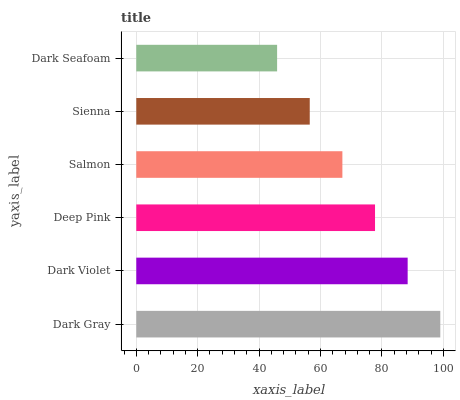Is Dark Seafoam the minimum?
Answer yes or no. Yes. Is Dark Gray the maximum?
Answer yes or no. Yes. Is Dark Violet the minimum?
Answer yes or no. No. Is Dark Violet the maximum?
Answer yes or no. No. Is Dark Gray greater than Dark Violet?
Answer yes or no. Yes. Is Dark Violet less than Dark Gray?
Answer yes or no. Yes. Is Dark Violet greater than Dark Gray?
Answer yes or no. No. Is Dark Gray less than Dark Violet?
Answer yes or no. No. Is Deep Pink the high median?
Answer yes or no. Yes. Is Salmon the low median?
Answer yes or no. Yes. Is Sienna the high median?
Answer yes or no. No. Is Dark Seafoam the low median?
Answer yes or no. No. 